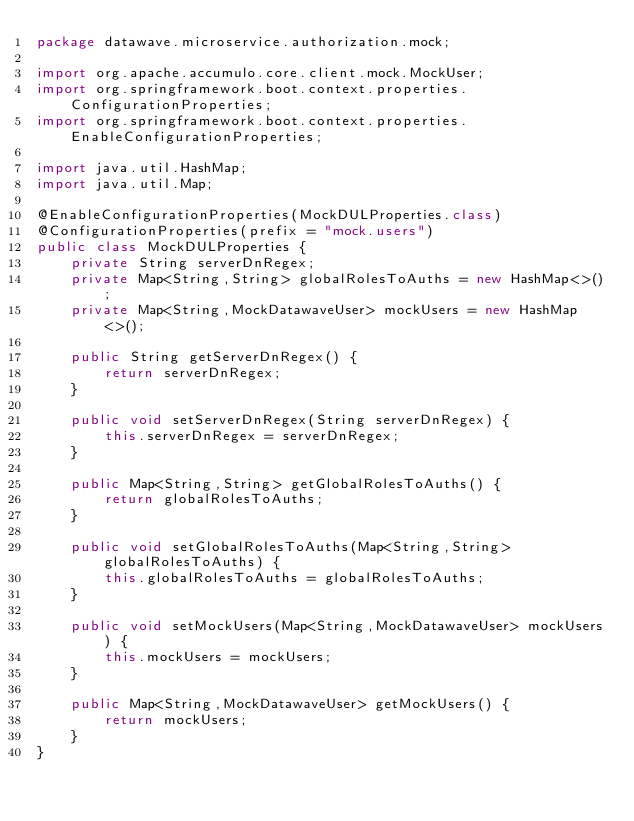Convert code to text. <code><loc_0><loc_0><loc_500><loc_500><_Java_>package datawave.microservice.authorization.mock;

import org.apache.accumulo.core.client.mock.MockUser;
import org.springframework.boot.context.properties.ConfigurationProperties;
import org.springframework.boot.context.properties.EnableConfigurationProperties;

import java.util.HashMap;
import java.util.Map;

@EnableConfigurationProperties(MockDULProperties.class)
@ConfigurationProperties(prefix = "mock.users")
public class MockDULProperties {
    private String serverDnRegex;
    private Map<String,String> globalRolesToAuths = new HashMap<>();
    private Map<String,MockDatawaveUser> mockUsers = new HashMap<>();
    
    public String getServerDnRegex() {
        return serverDnRegex;
    }
    
    public void setServerDnRegex(String serverDnRegex) {
        this.serverDnRegex = serverDnRegex;
    }
    
    public Map<String,String> getGlobalRolesToAuths() {
        return globalRolesToAuths;
    }
    
    public void setGlobalRolesToAuths(Map<String,String> globalRolesToAuths) {
        this.globalRolesToAuths = globalRolesToAuths;
    }
    
    public void setMockUsers(Map<String,MockDatawaveUser> mockUsers) {
        this.mockUsers = mockUsers;
    }
    
    public Map<String,MockDatawaveUser> getMockUsers() {
        return mockUsers;
    }
}
</code> 